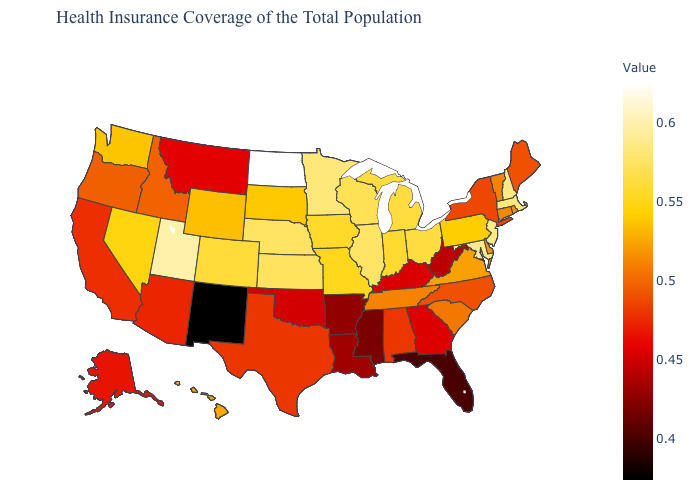Which states hav the highest value in the South?
Keep it brief. Maryland. Does Wisconsin have a higher value than North Dakota?
Keep it brief. No. 